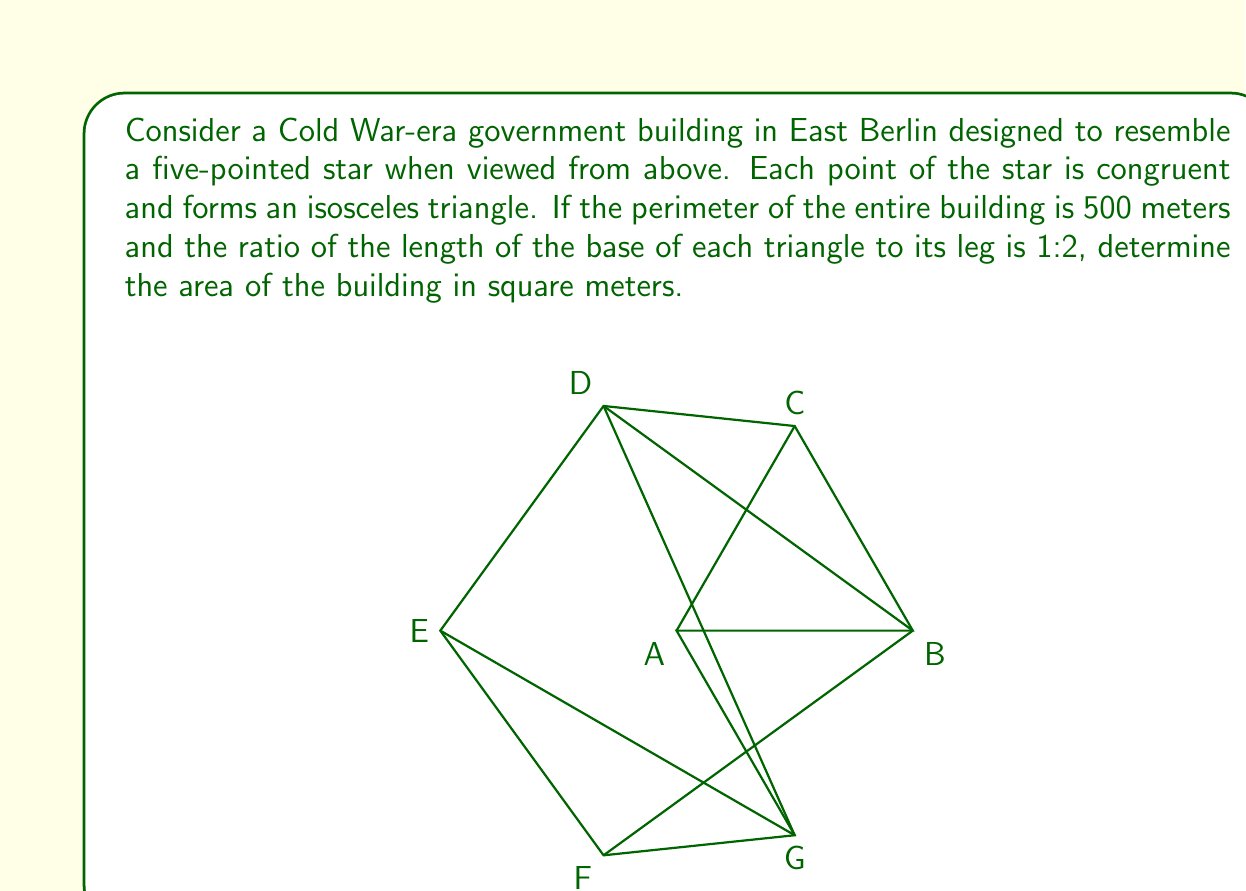Teach me how to tackle this problem. Let's approach this step-by-step:

1) First, we need to understand the geometry of the star. It consists of 5 congruent isosceles triangles.

2) Let's denote the base of each triangle as $b$ and the leg as $l$. We're given that $b:l = 1:2$, so $l = 2b$.

3) The perimeter of the star is 500 meters. This is equal to $5b + 5l = 5b + 5(2b) = 15b$.
   So, $15b = 500$, and $b = \frac{500}{15} \approx 33.33$ meters.

4) Now we know $b$, we can calculate $l$: $l = 2b \approx 66.67$ meters.

5) To find the area of the star, we need to find the area of one triangle and multiply by 5.

6) The area of an isosceles triangle is given by $A = \frac{1}{2}bh$, where $h$ is the height.

7) To find $h$, we can use the Pythagorean theorem:
   $h^2 + (\frac{b}{2})^2 = l^2$
   $h^2 + (\frac{33.33}{2})^2 = 66.67^2$
   $h^2 \approx 4444.44 - 277.78 = 4166.66$
   $h \approx \sqrt{4166.66} \approx 64.55$ meters

8) Now we can calculate the area of one triangle:
   $A = \frac{1}{2} * 33.33 * 64.55 \approx 1075.83$ square meters

9) The total area of the star is $5 * 1075.83 \approx 5379.15$ square meters
Answer: $5379.15$ $\text{m}^2$ 